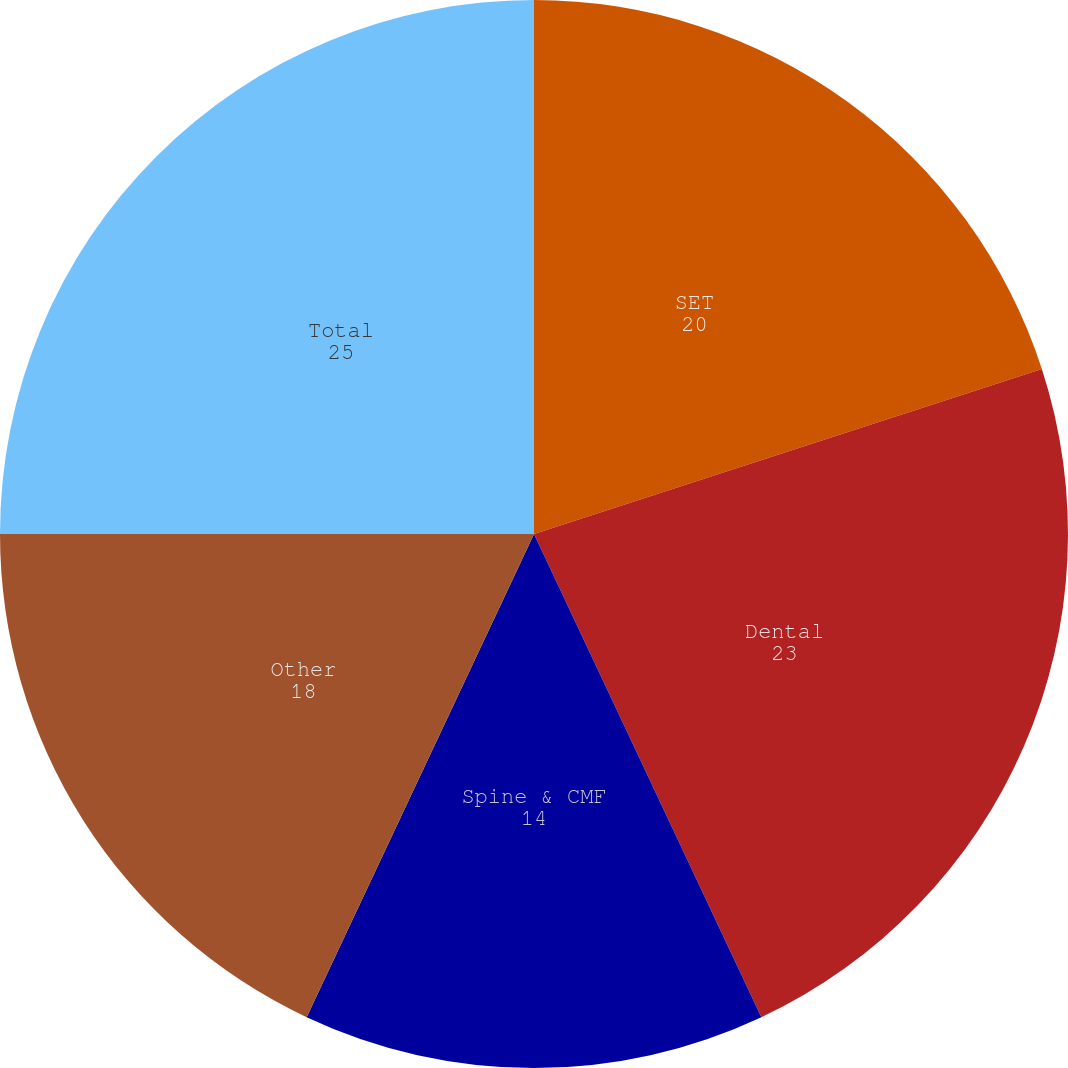Convert chart. <chart><loc_0><loc_0><loc_500><loc_500><pie_chart><fcel>SET<fcel>Dental<fcel>Spine & CMF<fcel>Other<fcel>Total<nl><fcel>20.0%<fcel>23.0%<fcel>14.0%<fcel>18.0%<fcel>25.0%<nl></chart> 